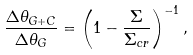<formula> <loc_0><loc_0><loc_500><loc_500>\frac { \Delta \theta _ { G + C } } { \Delta \theta _ { G } } = \left ( 1 - \frac { \Sigma } { \Sigma _ { c r } } \right ) ^ { - 1 } ,</formula> 